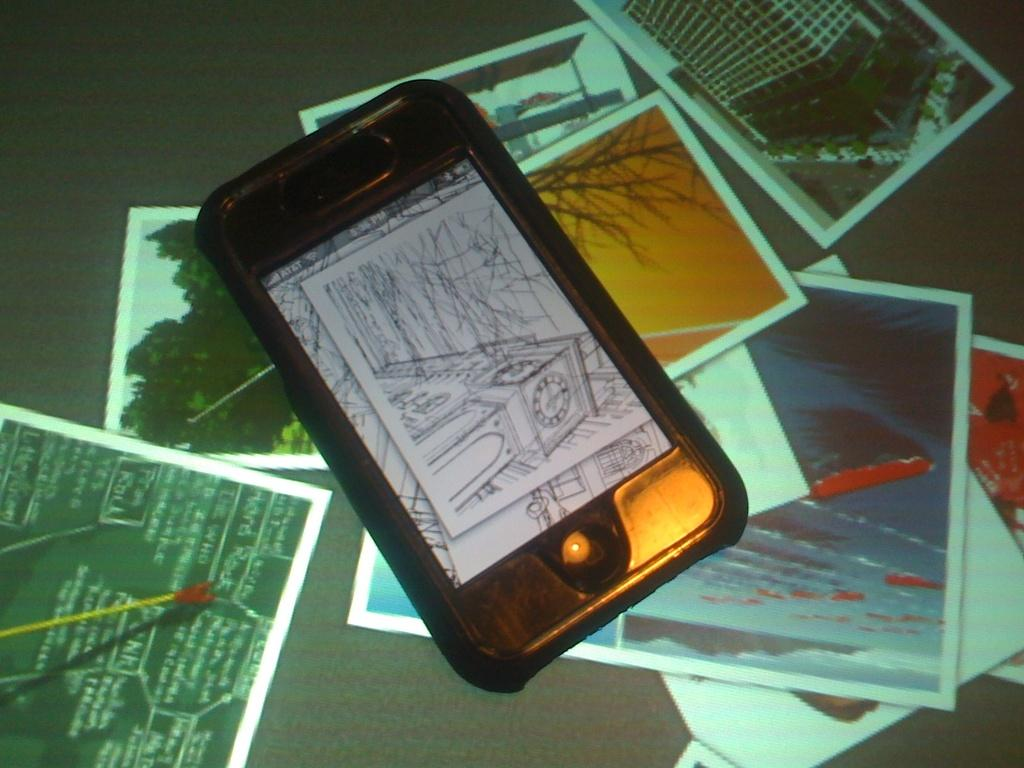What type of items are displayed in the image? There are different photographs in the image. Can you describe any other objects in the image? There is a mobile in the image. What can be seen on the mobile? Images are visible on the mobile. Is there any blood visible on the sofa in the image? There is no sofa or blood present in the image; it only features photographs and a mobile. 